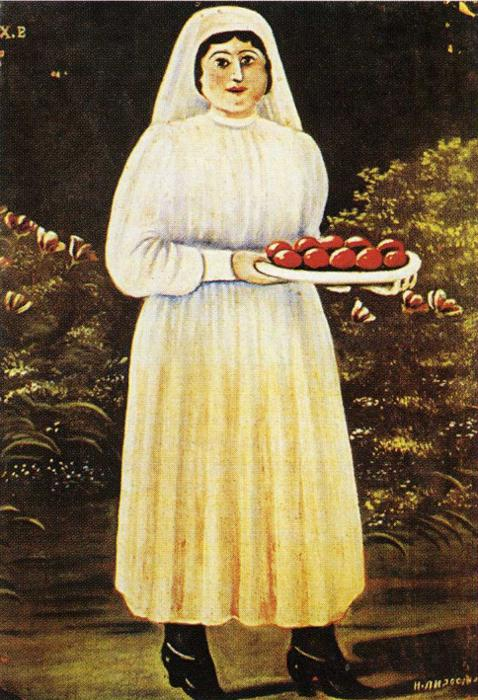Let’s imagine this painting is a portal to another world; what kind of world would it be? Imagine stepping through the painting into an idyllic, verdant realm where nature and humanity exist in perfect symbiosis. The air is perpetually filled with the sweet scent of blossoms and ripe fruit, and every creature, from the smallest insect to the tallest tree, thrives in harmony. The woman is a revered guardian of this world, her tray of apples a symbol of prosperity and balance. In this world, community rituals revolve around the bounty of the land, and each season brings its own unique celebrations of life, growth, and renewal. 